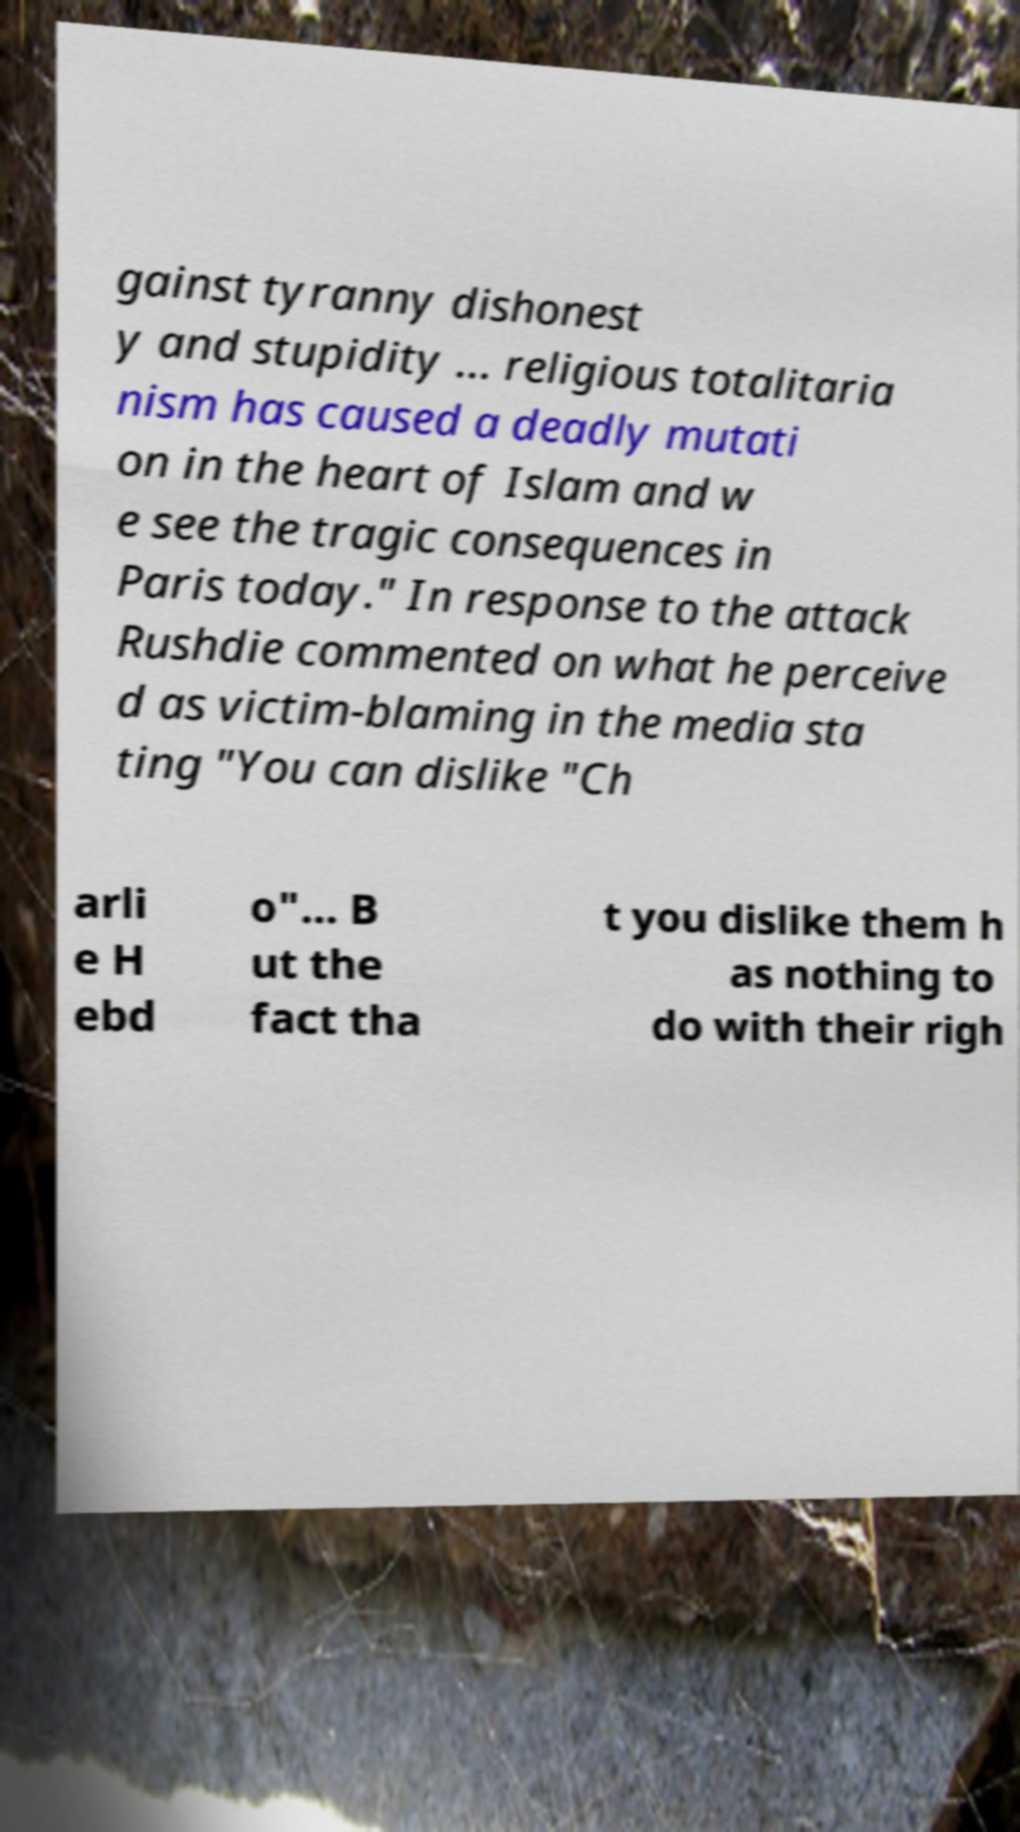There's text embedded in this image that I need extracted. Can you transcribe it verbatim? gainst tyranny dishonest y and stupidity ... religious totalitaria nism has caused a deadly mutati on in the heart of Islam and w e see the tragic consequences in Paris today." In response to the attack Rushdie commented on what he perceive d as victim-blaming in the media sta ting "You can dislike "Ch arli e H ebd o"... B ut the fact tha t you dislike them h as nothing to do with their righ 